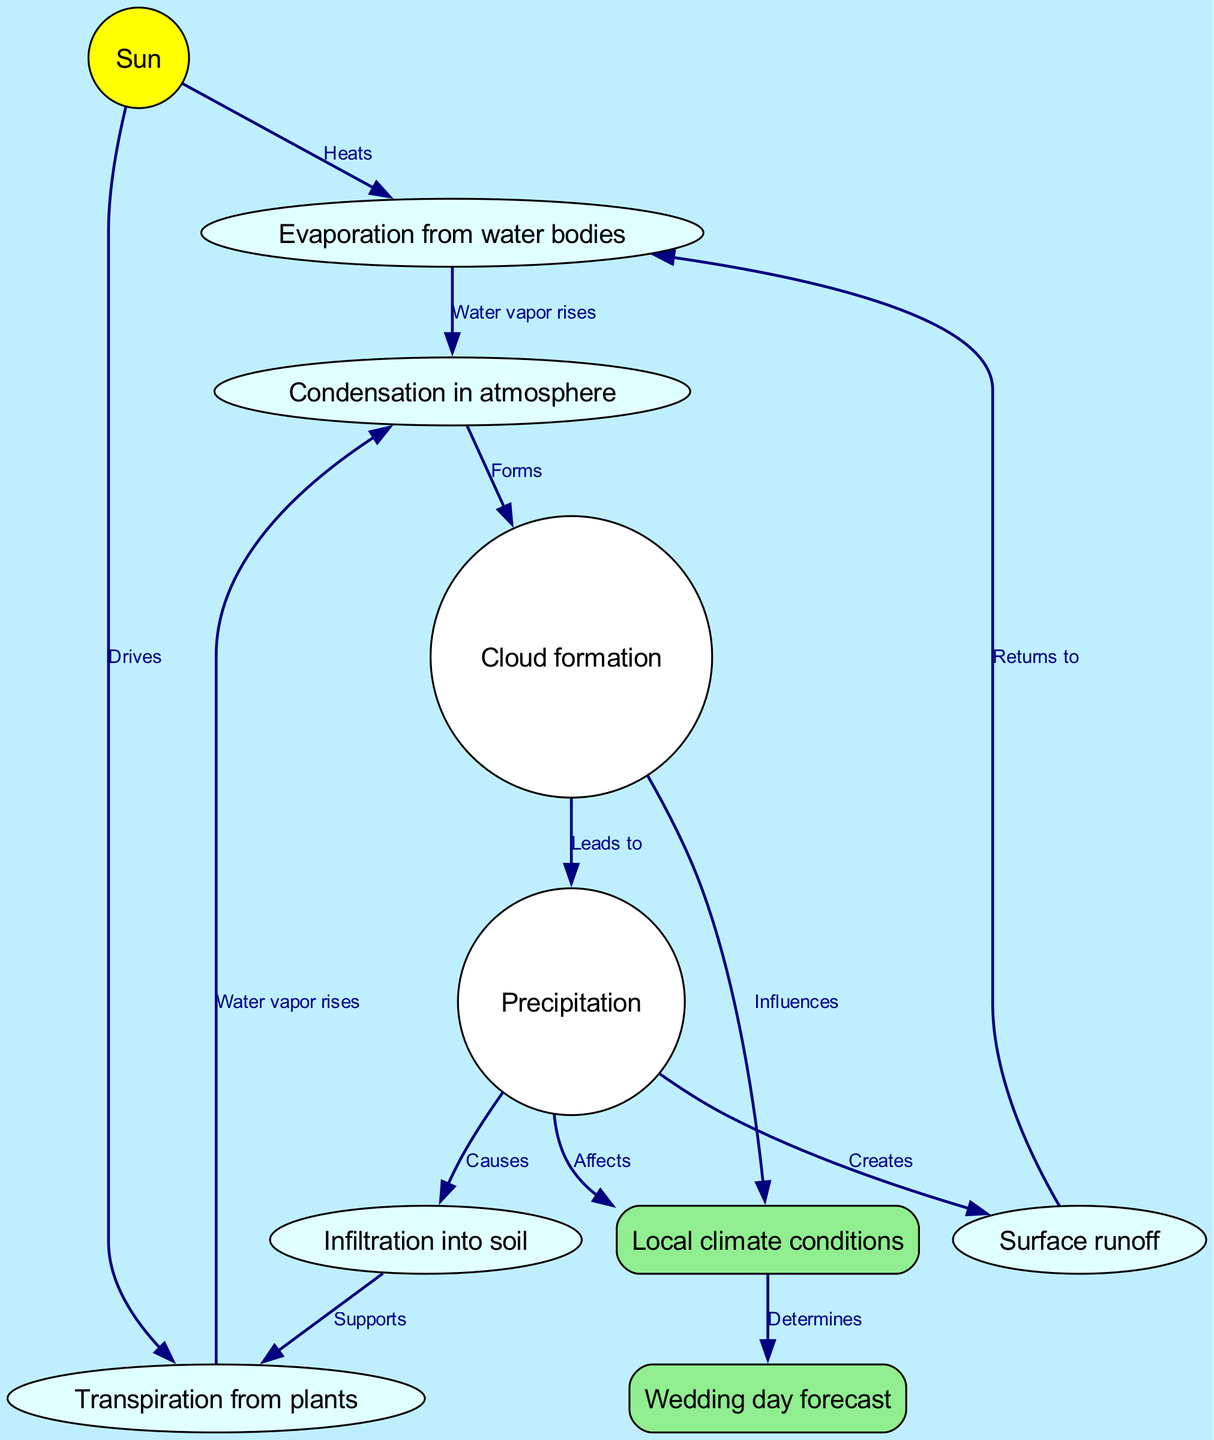What is the first step of the water cycle? The first step indicated in the diagram is evaporation from water bodies, which is driven by the heat from the sun.
Answer: Evaporation from water bodies How many nodes are in the diagram? The diagram contains a total of 10 nodes that represent various processes and components of the water cycle.
Answer: 10 nodes What leads to precipitation? The diagram shows that cloud formation leads to precipitation, indicating how water vapor accumulates in clouds before falling as rain or snow.
Answer: Cloud formation Which process influences local climate? The diagram specifies that clouds influence local climate, emphasizing their role in determining weather conditions.
Answer: Clouds What does infiltration support? According to the diagram, infiltration supports transpiration, which shows the interconnectedness of water movement between soil and plants.
Answer: Transpiration What determines wedding day forecast? The diagram illustrates that local climate conditions determine the wedding day forecast, highlighting the importance of climate in planning outdoor events.
Answer: Local climate conditions How many edges connect the nodes? The diagram has 13 edges, each representing a relationship or flow between different components of the water cycle.
Answer: 13 edges Which element is heated by the sun? The sun heats both evaporation from water bodies and transpiration from plants, demonstrating the sun's role in initiating the water cycle.
Answer: Evaporation from water bodies and Transpiration from plants What is formed from condensation? The diagram indicates that condensation in the atmosphere forms clouds, representing how moisture accumulates before falling as precipitation.
Answer: Clouds 